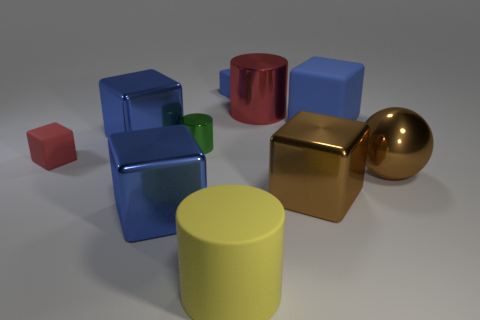Subtract all brown cylinders. How many blue cubes are left? 4 Subtract all red cubes. How many cubes are left? 5 Subtract all red matte cubes. How many cubes are left? 5 Subtract 3 blocks. How many blocks are left? 3 Subtract all purple blocks. Subtract all purple cylinders. How many blocks are left? 6 Subtract all cubes. How many objects are left? 4 Subtract all large yellow shiny cylinders. Subtract all big red cylinders. How many objects are left? 9 Add 8 green objects. How many green objects are left? 9 Add 9 blue balls. How many blue balls exist? 9 Subtract 0 gray cylinders. How many objects are left? 10 